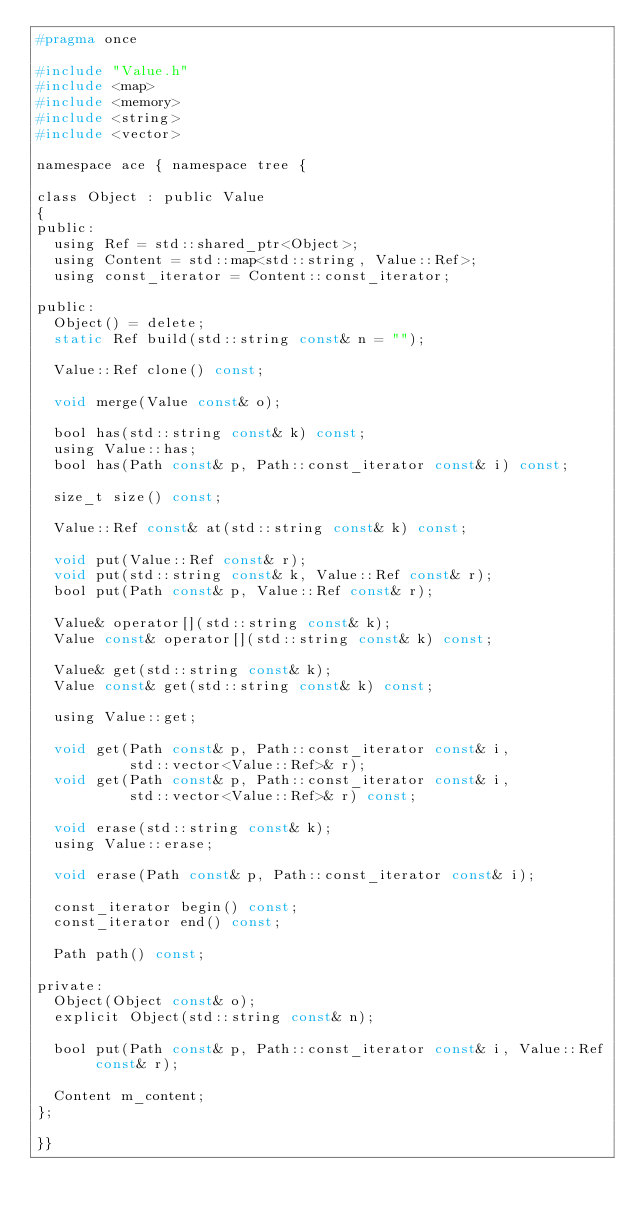Convert code to text. <code><loc_0><loc_0><loc_500><loc_500><_C_>#pragma once

#include "Value.h"
#include <map>
#include <memory>
#include <string>
#include <vector>

namespace ace { namespace tree {

class Object : public Value
{
public:
  using Ref = std::shared_ptr<Object>;
  using Content = std::map<std::string, Value::Ref>;
  using const_iterator = Content::const_iterator;

public:
  Object() = delete;
  static Ref build(std::string const& n = "");

  Value::Ref clone() const;

  void merge(Value const& o);

  bool has(std::string const& k) const;
  using Value::has;
  bool has(Path const& p, Path::const_iterator const& i) const;

  size_t size() const;

  Value::Ref const& at(std::string const& k) const;

  void put(Value::Ref const& r);
  void put(std::string const& k, Value::Ref const& r);
  bool put(Path const& p, Value::Ref const& r);

  Value& operator[](std::string const& k);
  Value const& operator[](std::string const& k) const;

  Value& get(std::string const& k);
  Value const& get(std::string const& k) const;

  using Value::get;

  void get(Path const& p, Path::const_iterator const& i,
           std::vector<Value::Ref>& r);
  void get(Path const& p, Path::const_iterator const& i,
           std::vector<Value::Ref>& r) const;

  void erase(std::string const& k);
  using Value::erase;

  void erase(Path const& p, Path::const_iterator const& i);

  const_iterator begin() const;
  const_iterator end() const;

  Path path() const;

private:
  Object(Object const& o);
  explicit Object(std::string const& n);

  bool put(Path const& p, Path::const_iterator const& i, Value::Ref const& r);

  Content m_content;
};

}}
</code> 